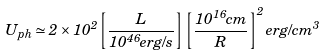Convert formula to latex. <formula><loc_0><loc_0><loc_500><loc_500>U _ { p h } \simeq 2 \times 1 0 ^ { 2 } \left [ \frac { L } { 1 0 ^ { 4 6 } e r g / s } \right ] \left [ \frac { 1 0 ^ { 1 6 } c m } { R } \right ] ^ { 2 } e r g / c m ^ { 3 }</formula> 